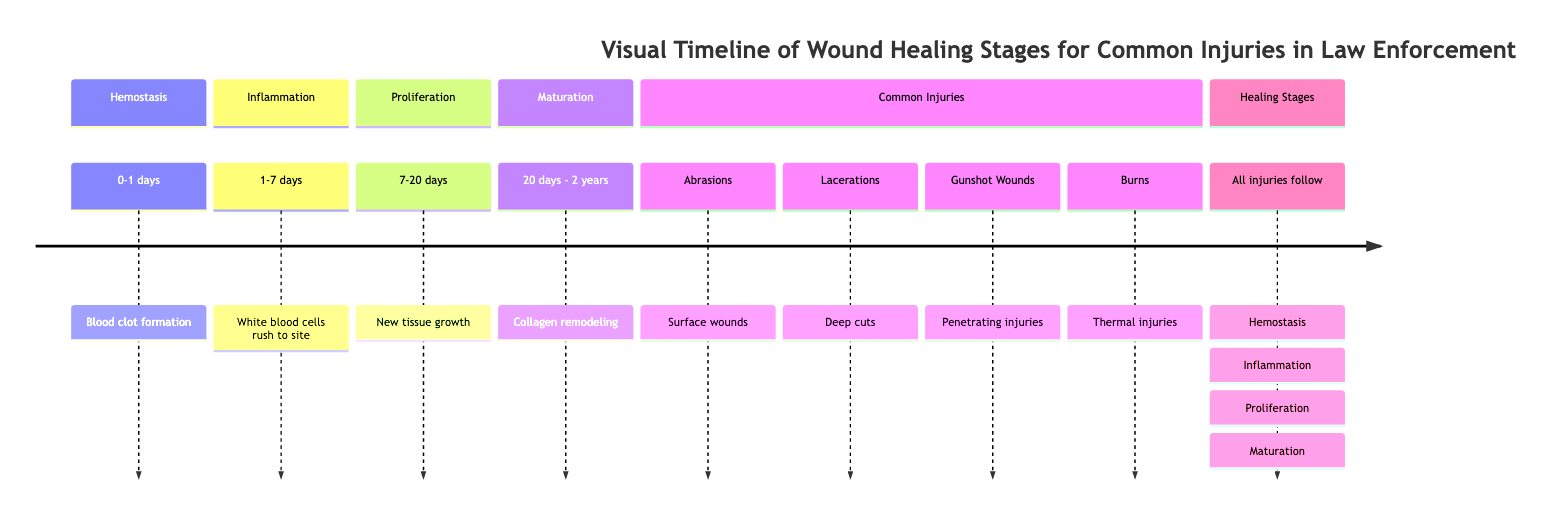What are the stages of wound healing depicted? The timeline includes four distinct stages of wound healing: Hemostasis, Inflammation, Proliferation, and Maturation. Each stage is represented in the diagram, with specific timeframes outlined for each.
Answer: Hemostasis, Inflammation, Proliferation, Maturation How long does the Proliferation stage last? According to the diagram, the Proliferation stage lasts from 7 to 20 days. This duration is explicitly noted in the visual timeline, making it easy to identify.
Answer: 7-20 days What is the first step in the wound healing process? The diagram clearly states that the first step in the wound healing process is Hemostasis, which occurs within the first day. This is a foundational part of the timeline illustrated.
Answer: Hemostasis Which type of injury requires the longest healing period? Analyzing the diagram indicates that while all injuries follow the same healing stages, the specific types listed (abrasions, lacerations, gunshot wounds, burns) do not dictate healing time. However, severe injuries like gunshot wounds often indicate longer healing times implicitly, though not explicitly stated. Hence, gunshot wounds can be inferred to have the longest healing period.
Answer: Gunshot Wounds What happens during the Inflammation stage? The timeline notes that during the Inflammation stage, white blood cells rush to the site of the injury. This is a crucial part of the healing process where the body starts addressing the damage.
Answer: White blood cells rush to site How long does it take for collagen remodeling to occur? The diagram specifies that collagen remodeling occurs from 20 days to 2 years during the Maturation stage. This gives a clear temporal range for this critical process in healing.
Answer: 20 days - 2 years How many common injury types are listed? The diagram lists four common types of injuries which are abrasions, lacerations, gunshot wounds, and burns. This count can be easily assessed from the section designated for common injuries.
Answer: 4 What stage follows Inflammation? The diagram indicates that the stage that follows Inflammation is Proliferation. By reading the sequential order of the stages, it is straightforward to identify this relationship.
Answer: Proliferation What is the purpose of Hemostasis in wound healing? The diagram illustrates that Hemostasis is the process of blood clot formation, which is critical in the initial response to injury to prevent excessive blood loss. Understanding this role clarifies its importance in the overall healing process.
Answer: Blood clot formation 